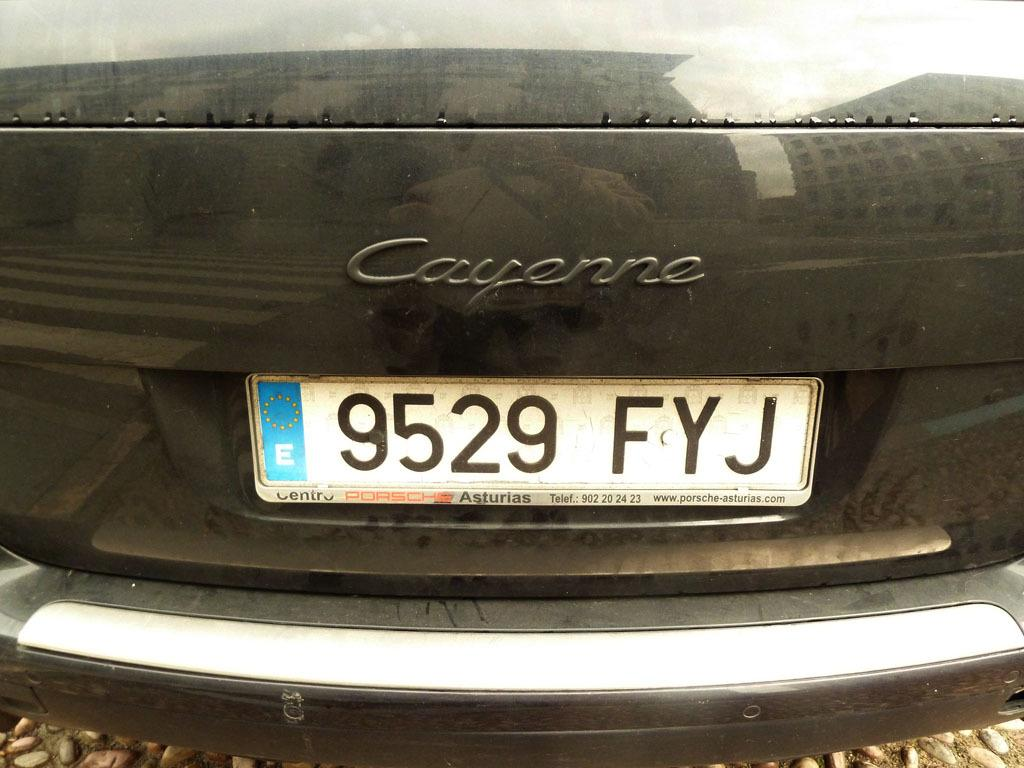<image>
Offer a succinct explanation of the picture presented. A black Cayenne has a license plate number of 9529 FYJ. 